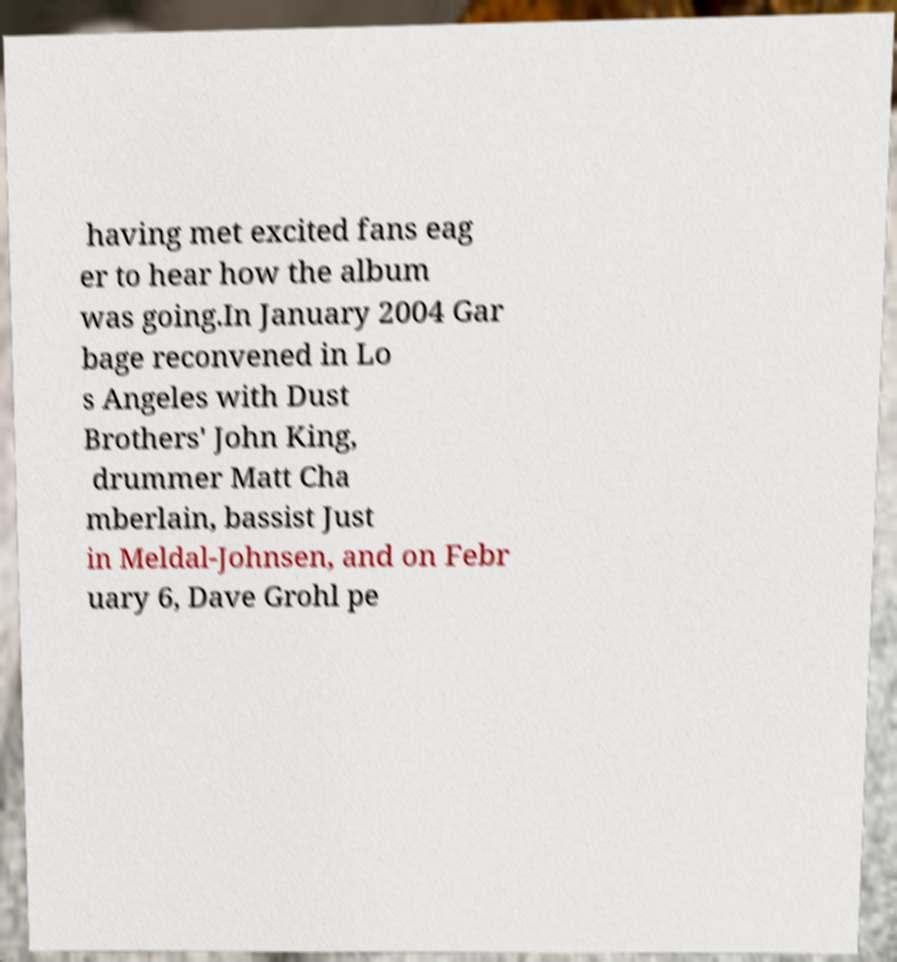There's text embedded in this image that I need extracted. Can you transcribe it verbatim? having met excited fans eag er to hear how the album was going.In January 2004 Gar bage reconvened in Lo s Angeles with Dust Brothers' John King, drummer Matt Cha mberlain, bassist Just in Meldal-Johnsen, and on Febr uary 6, Dave Grohl pe 